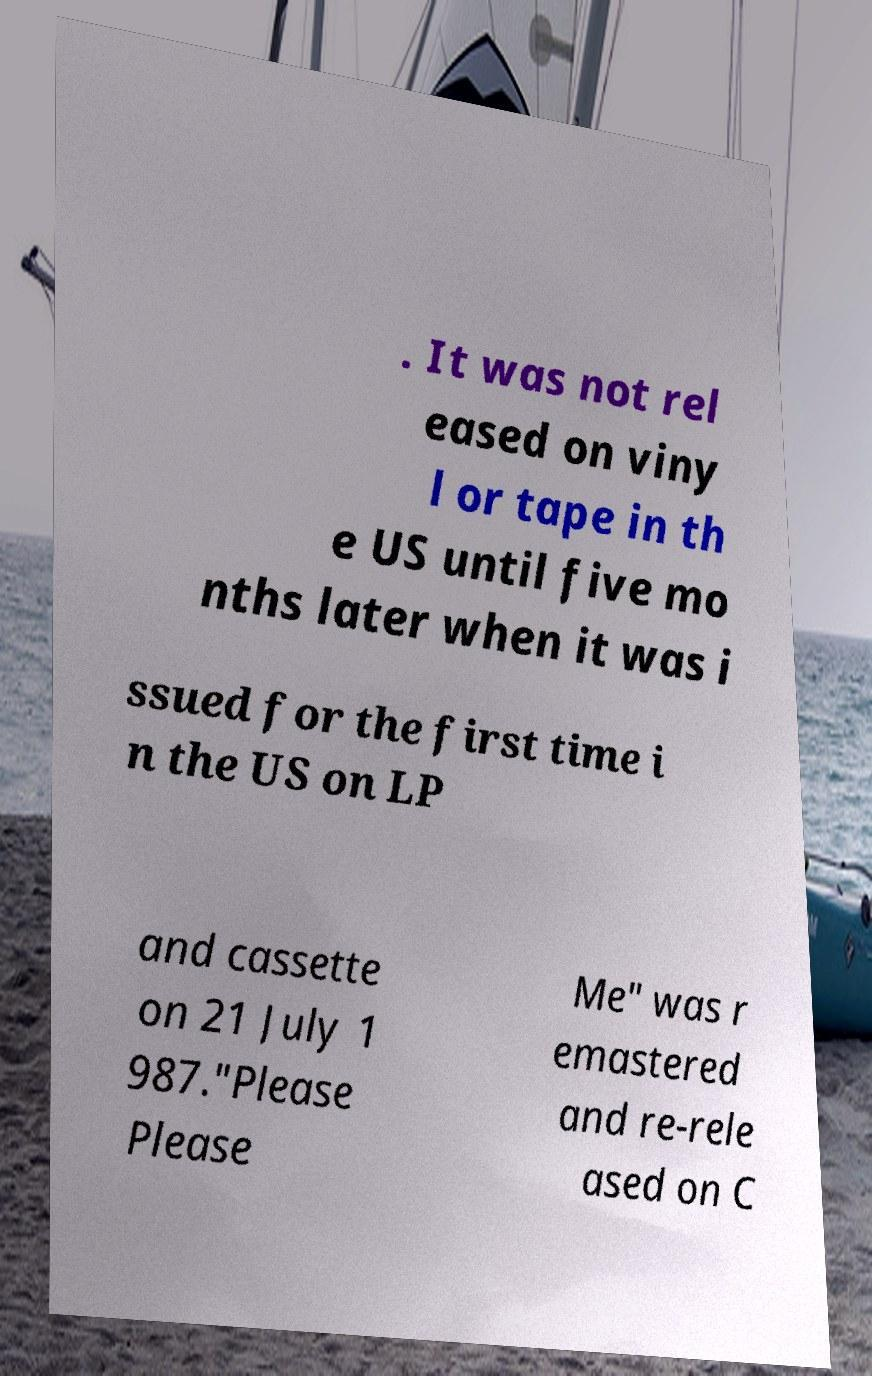Can you read and provide the text displayed in the image?This photo seems to have some interesting text. Can you extract and type it out for me? . It was not rel eased on viny l or tape in th e US until five mo nths later when it was i ssued for the first time i n the US on LP and cassette on 21 July 1 987."Please Please Me" was r emastered and re-rele ased on C 